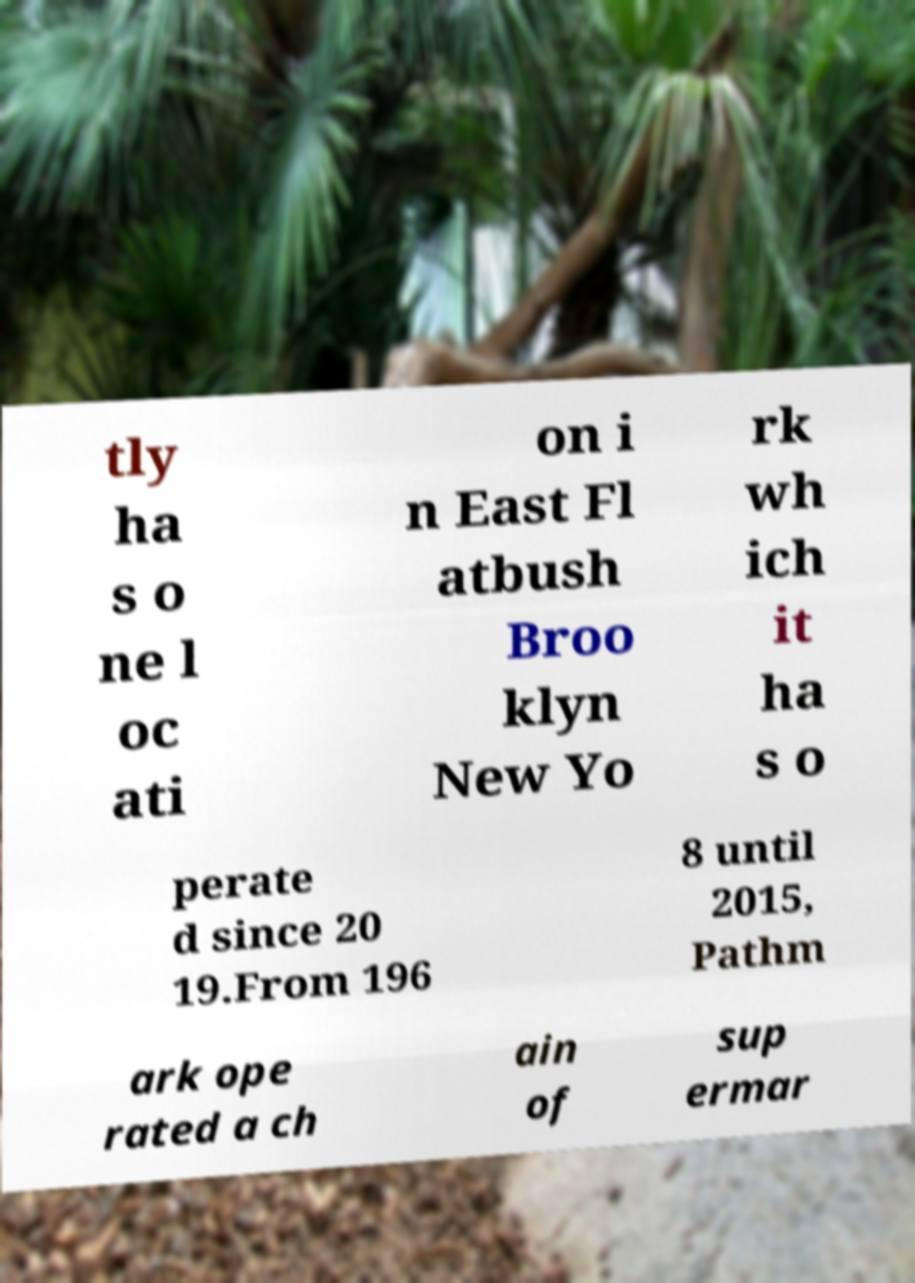Can you read and provide the text displayed in the image?This photo seems to have some interesting text. Can you extract and type it out for me? tly ha s o ne l oc ati on i n East Fl atbush Broo klyn New Yo rk wh ich it ha s o perate d since 20 19.From 196 8 until 2015, Pathm ark ope rated a ch ain of sup ermar 